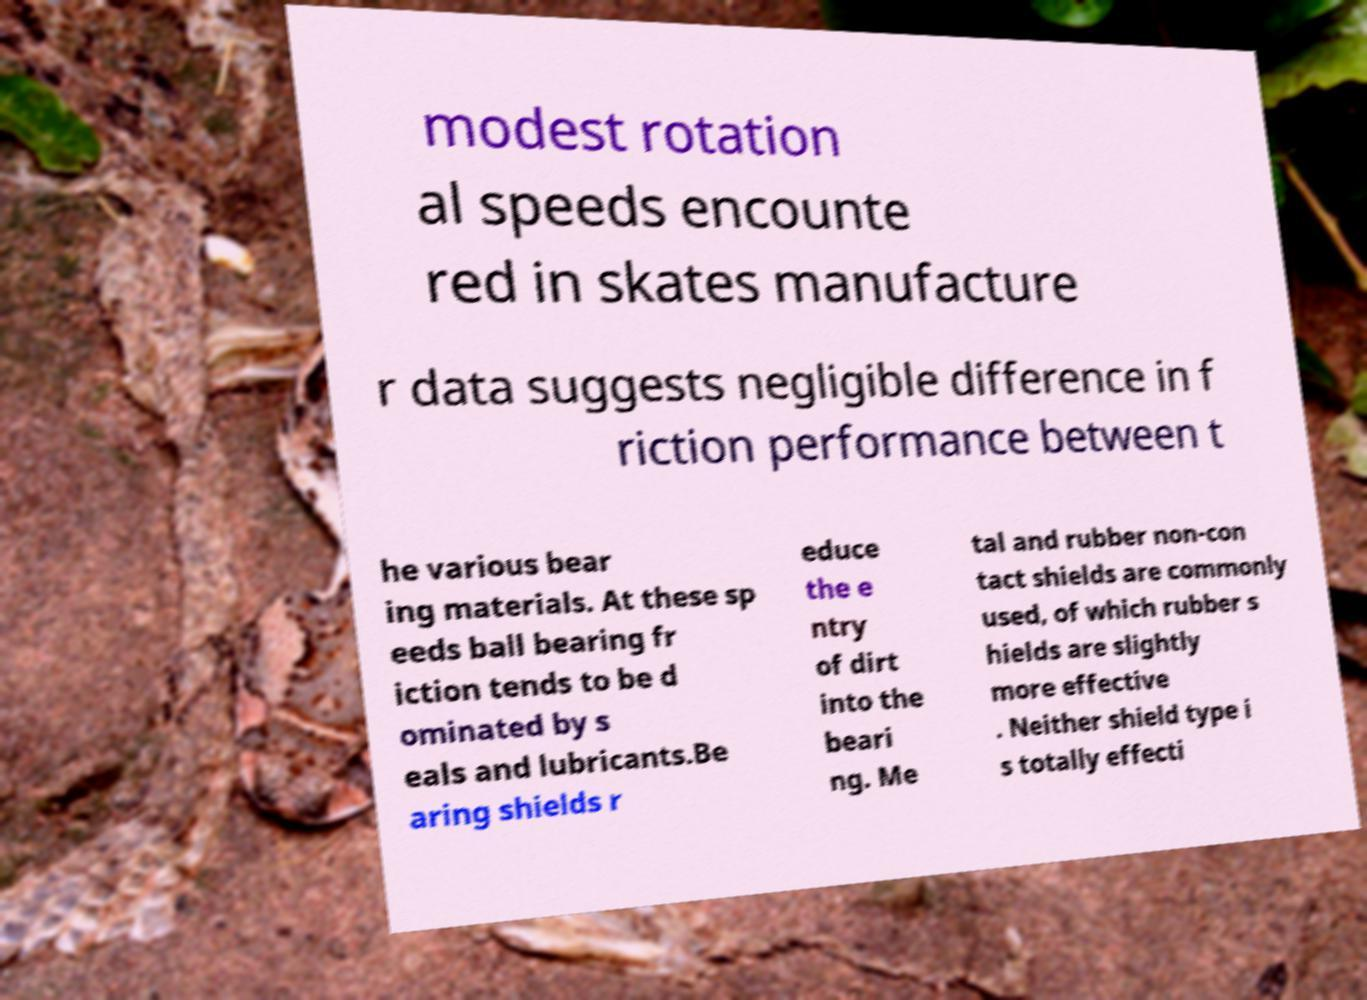Could you extract and type out the text from this image? modest rotation al speeds encounte red in skates manufacture r data suggests negligible difference in f riction performance between t he various bear ing materials. At these sp eeds ball bearing fr iction tends to be d ominated by s eals and lubricants.Be aring shields r educe the e ntry of dirt into the beari ng. Me tal and rubber non-con tact shields are commonly used, of which rubber s hields are slightly more effective . Neither shield type i s totally effecti 